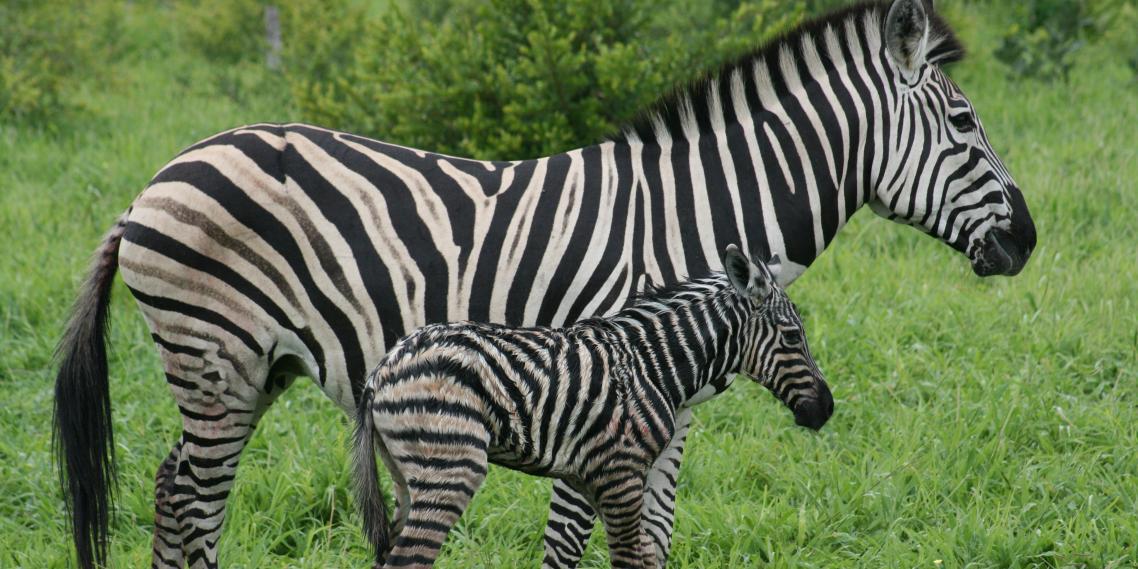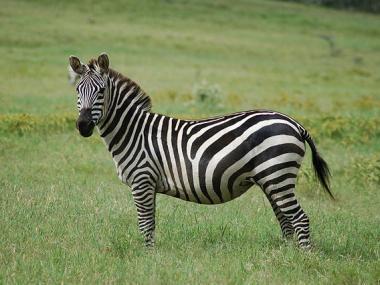The first image is the image on the left, the second image is the image on the right. Examine the images to the left and right. Is the description "There are two zebras, one adult and one child facing right." accurate? Answer yes or no. Yes. The first image is the image on the left, the second image is the image on the right. Examine the images to the left and right. Is the description "There are three zebras and one of them is a juvenile." accurate? Answer yes or no. Yes. 